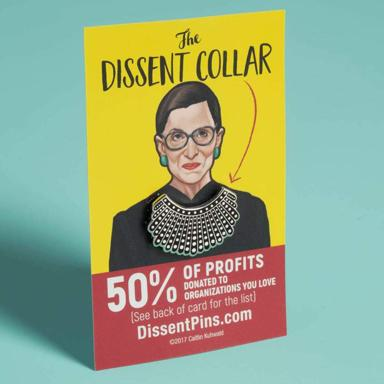How has the Dissent Collar become a symbol in popular culture? The Dissent Collar gained symbolical significance primarily due to Justice Ruth Bader Ginsburg's use of it as a form of sartorial protest. Whenever Ginsburg disagreed with a majority opinion on the Supreme Court, she would don this type of embellished collar, turning a piece of jewelry into a powerful symbol of dissent and resistance. This practice resonated with many who saw it as an expression of judicial independence and defiance. Over time, it became an icon of empowerment and a rallying symbol for various movements fighting for equality and justice. 